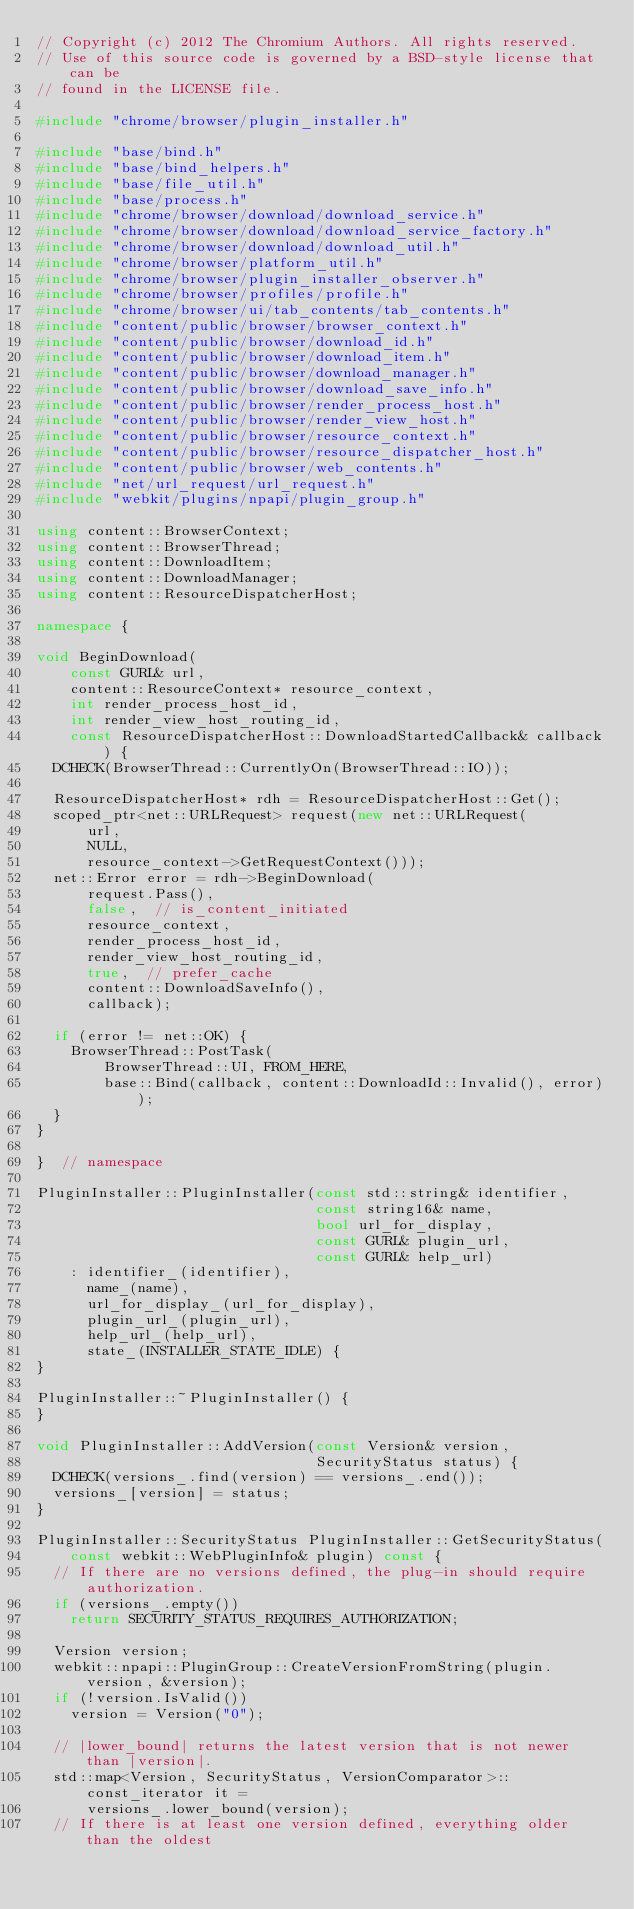Convert code to text. <code><loc_0><loc_0><loc_500><loc_500><_C++_>// Copyright (c) 2012 The Chromium Authors. All rights reserved.
// Use of this source code is governed by a BSD-style license that can be
// found in the LICENSE file.

#include "chrome/browser/plugin_installer.h"

#include "base/bind.h"
#include "base/bind_helpers.h"
#include "base/file_util.h"
#include "base/process.h"
#include "chrome/browser/download/download_service.h"
#include "chrome/browser/download/download_service_factory.h"
#include "chrome/browser/download/download_util.h"
#include "chrome/browser/platform_util.h"
#include "chrome/browser/plugin_installer_observer.h"
#include "chrome/browser/profiles/profile.h"
#include "chrome/browser/ui/tab_contents/tab_contents.h"
#include "content/public/browser/browser_context.h"
#include "content/public/browser/download_id.h"
#include "content/public/browser/download_item.h"
#include "content/public/browser/download_manager.h"
#include "content/public/browser/download_save_info.h"
#include "content/public/browser/render_process_host.h"
#include "content/public/browser/render_view_host.h"
#include "content/public/browser/resource_context.h"
#include "content/public/browser/resource_dispatcher_host.h"
#include "content/public/browser/web_contents.h"
#include "net/url_request/url_request.h"
#include "webkit/plugins/npapi/plugin_group.h"

using content::BrowserContext;
using content::BrowserThread;
using content::DownloadItem;
using content::DownloadManager;
using content::ResourceDispatcherHost;

namespace {

void BeginDownload(
    const GURL& url,
    content::ResourceContext* resource_context,
    int render_process_host_id,
    int render_view_host_routing_id,
    const ResourceDispatcherHost::DownloadStartedCallback& callback) {
  DCHECK(BrowserThread::CurrentlyOn(BrowserThread::IO));

  ResourceDispatcherHost* rdh = ResourceDispatcherHost::Get();
  scoped_ptr<net::URLRequest> request(new net::URLRequest(
      url,
      NULL,
      resource_context->GetRequestContext()));
  net::Error error = rdh->BeginDownload(
      request.Pass(),
      false,  // is_content_initiated
      resource_context,
      render_process_host_id,
      render_view_host_routing_id,
      true,  // prefer_cache
      content::DownloadSaveInfo(),
      callback);

  if (error != net::OK) {
    BrowserThread::PostTask(
        BrowserThread::UI, FROM_HERE,
        base::Bind(callback, content::DownloadId::Invalid(), error));
  }
}

}  // namespace

PluginInstaller::PluginInstaller(const std::string& identifier,
                                 const string16& name,
                                 bool url_for_display,
                                 const GURL& plugin_url,
                                 const GURL& help_url)
    : identifier_(identifier),
      name_(name),
      url_for_display_(url_for_display),
      plugin_url_(plugin_url),
      help_url_(help_url),
      state_(INSTALLER_STATE_IDLE) {
}

PluginInstaller::~PluginInstaller() {
}

void PluginInstaller::AddVersion(const Version& version,
                                 SecurityStatus status) {
  DCHECK(versions_.find(version) == versions_.end());
  versions_[version] = status;
}

PluginInstaller::SecurityStatus PluginInstaller::GetSecurityStatus(
    const webkit::WebPluginInfo& plugin) const {
  // If there are no versions defined, the plug-in should require authorization.
  if (versions_.empty())
    return SECURITY_STATUS_REQUIRES_AUTHORIZATION;

  Version version;
  webkit::npapi::PluginGroup::CreateVersionFromString(plugin.version, &version);
  if (!version.IsValid())
    version = Version("0");

  // |lower_bound| returns the latest version that is not newer than |version|.
  std::map<Version, SecurityStatus, VersionComparator>::const_iterator it =
      versions_.lower_bound(version);
  // If there is at least one version defined, everything older than the oldest</code> 